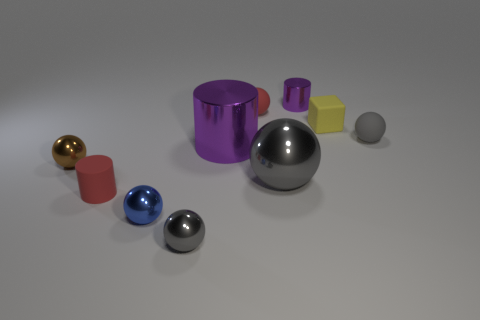Can you describe the lighting and shadows of the scene? The scene is evenly lit with soft, diffuse light creating gentle shadows. The objects cast slight shadows directly opposite the light source, suggesting a light source located above and slightly to the front left of the objects. 